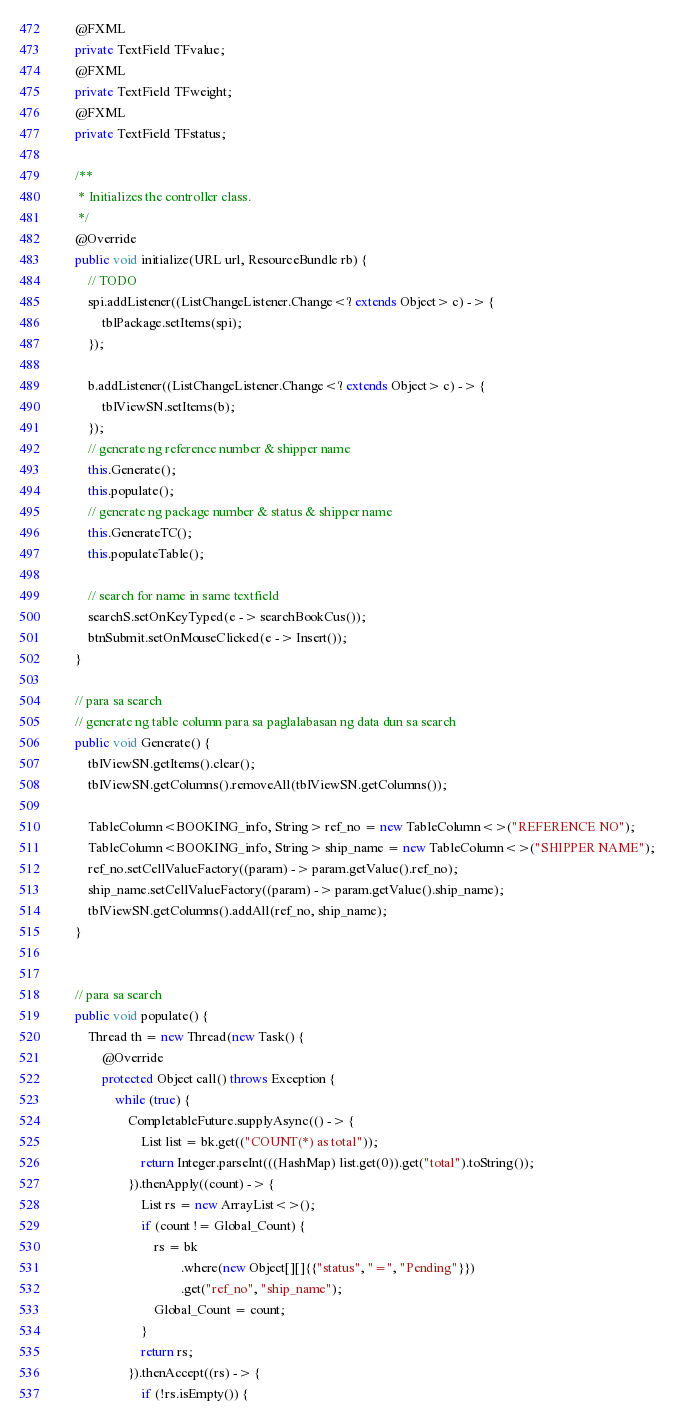Convert code to text. <code><loc_0><loc_0><loc_500><loc_500><_Java_>    @FXML
    private TextField TFvalue;
    @FXML
    private TextField TFweight;
    @FXML
    private TextField TFstatus;

    /**
     * Initializes the controller class.
     */
    @Override
    public void initialize(URL url, ResourceBundle rb) {
        // TODO
        spi.addListener((ListChangeListener.Change<? extends Object> c) -> {
            tblPackage.setItems(spi);
        });

        b.addListener((ListChangeListener.Change<? extends Object> c) -> {
            tblViewSN.setItems(b);
        });
        // generate ng reference number & shipper name
        this.Generate();
        this.populate();
        // generate ng package number & status & shipper name
        this.GenerateTC();
        this.populateTable();

        // search for name in same textfield
        searchS.setOnKeyTyped(e -> searchBookCus());
        btnSubmit.setOnMouseClicked(e -> Insert());
    }

    // para sa search
    // generate ng table column para sa paglalabasan ng data dun sa search
    public void Generate() {
        tblViewSN.getItems().clear();
        tblViewSN.getColumns().removeAll(tblViewSN.getColumns());

        TableColumn<BOOKING_info, String> ref_no = new TableColumn<>("REFERENCE NO");
        TableColumn<BOOKING_info, String> ship_name = new TableColumn<>("SHIPPER NAME");
        ref_no.setCellValueFactory((param) -> param.getValue().ref_no);
        ship_name.setCellValueFactory((param) -> param.getValue().ship_name);
        tblViewSN.getColumns().addAll(ref_no, ship_name);
    }


    // para sa search
    public void populate() {
        Thread th = new Thread(new Task() {
            @Override
            protected Object call() throws Exception {
                while (true) {
                    CompletableFuture.supplyAsync(() -> {
                        List list = bk.get(("COUNT(*) as total"));
                        return Integer.parseInt(((HashMap) list.get(0)).get("total").toString());
                    }).thenApply((count) -> {
                        List rs = new ArrayList<>();
                        if (count != Global_Count) {
                            rs = bk
                                    .where(new Object[][]{{"status", "=", "Pending"}})
                                    .get("ref_no", "ship_name");
                            Global_Count = count;
                        }
                        return rs;
                    }).thenAccept((rs) -> {
                        if (!rs.isEmpty()) {</code> 